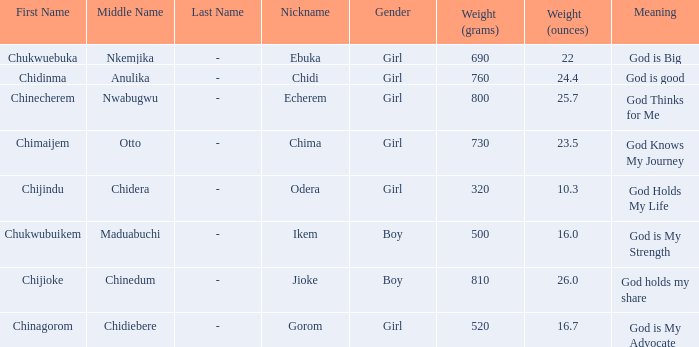Chukwubuikem Maduabuchi is what gender? Boy. 